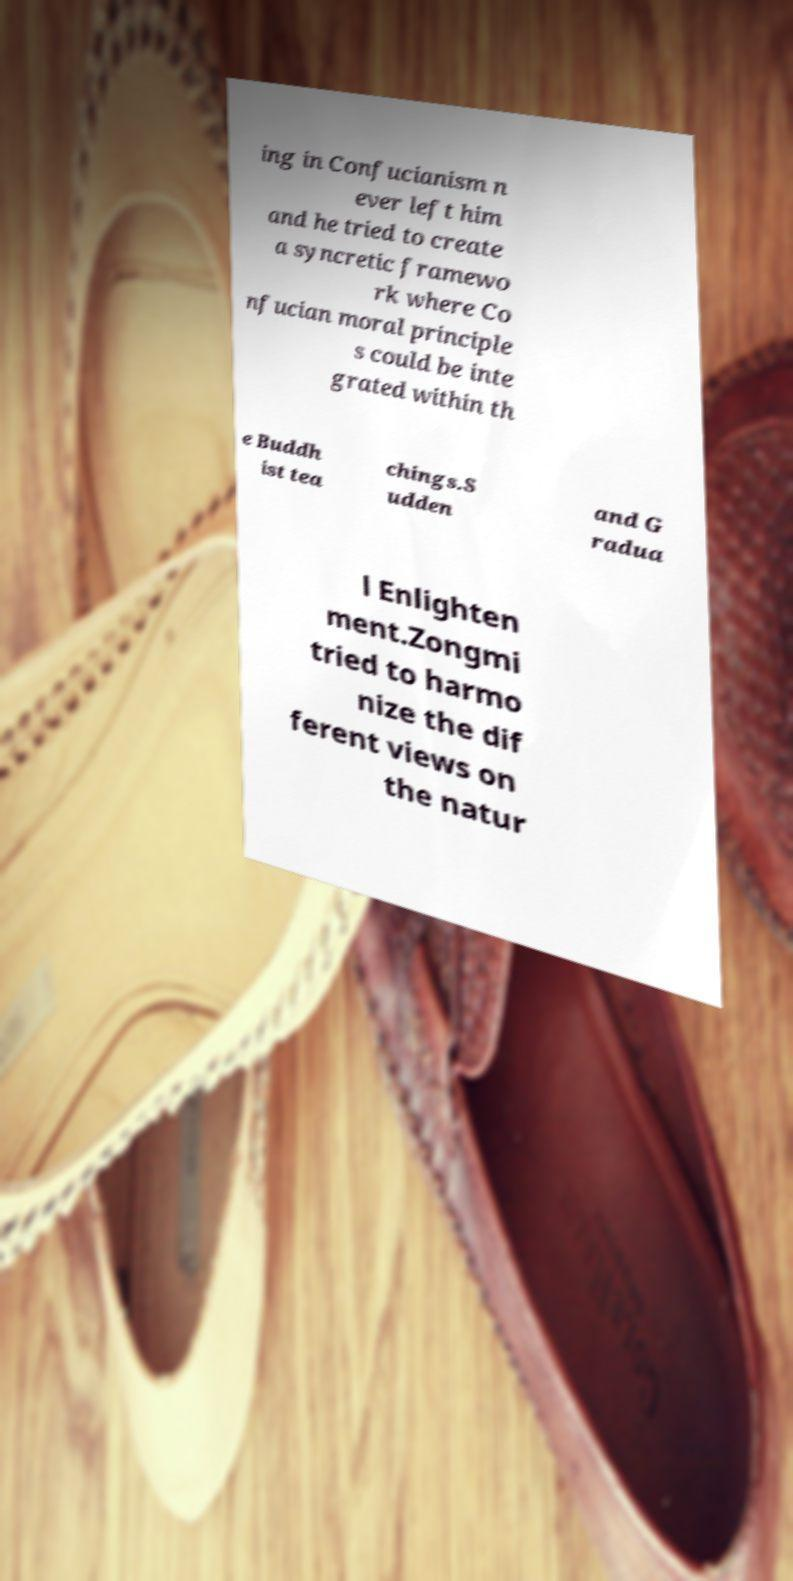Can you accurately transcribe the text from the provided image for me? ing in Confucianism n ever left him and he tried to create a syncretic framewo rk where Co nfucian moral principle s could be inte grated within th e Buddh ist tea chings.S udden and G radua l Enlighten ment.Zongmi tried to harmo nize the dif ferent views on the natur 